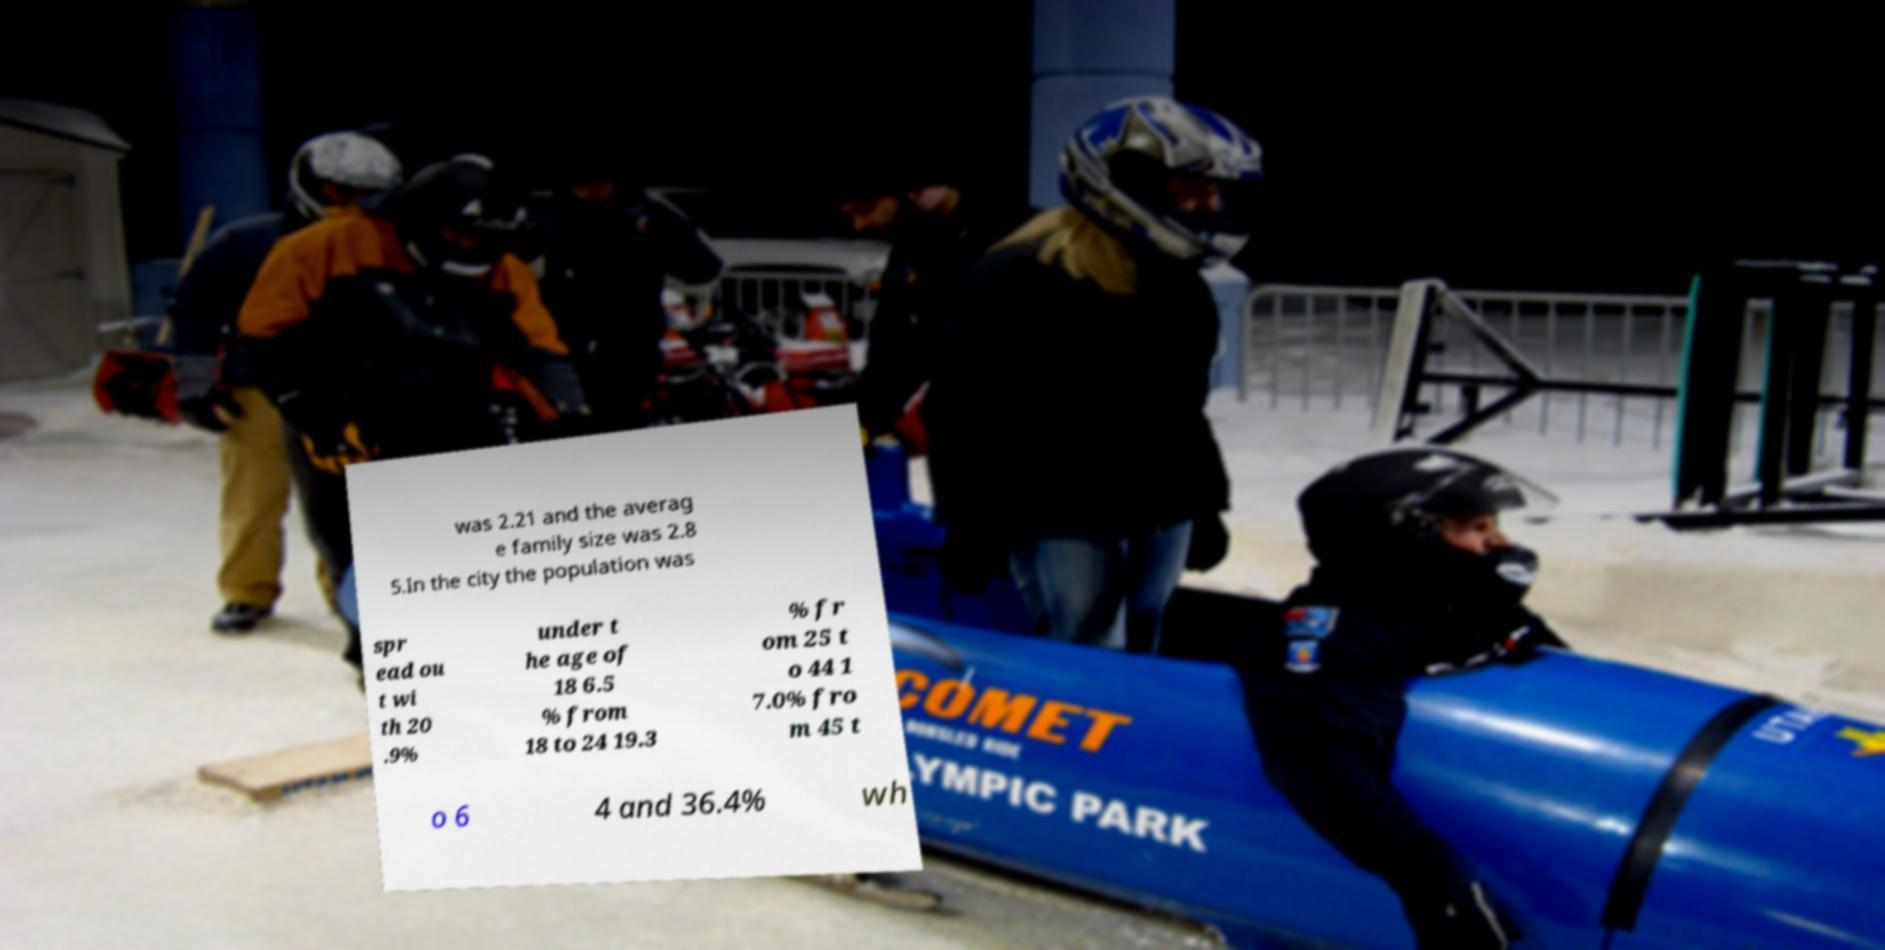Could you extract and type out the text from this image? was 2.21 and the averag e family size was 2.8 5.In the city the population was spr ead ou t wi th 20 .9% under t he age of 18 6.5 % from 18 to 24 19.3 % fr om 25 t o 44 1 7.0% fro m 45 t o 6 4 and 36.4% wh 